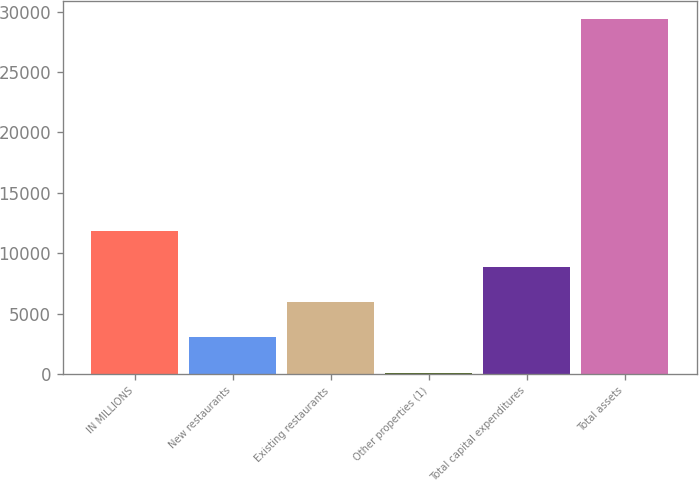Convert chart. <chart><loc_0><loc_0><loc_500><loc_500><bar_chart><fcel>IN MILLIONS<fcel>New restaurants<fcel>Existing restaurants<fcel>Other properties (1)<fcel>Total capital expenditures<fcel>Total assets<nl><fcel>11818<fcel>3031<fcel>5960<fcel>102<fcel>8889<fcel>29392<nl></chart> 